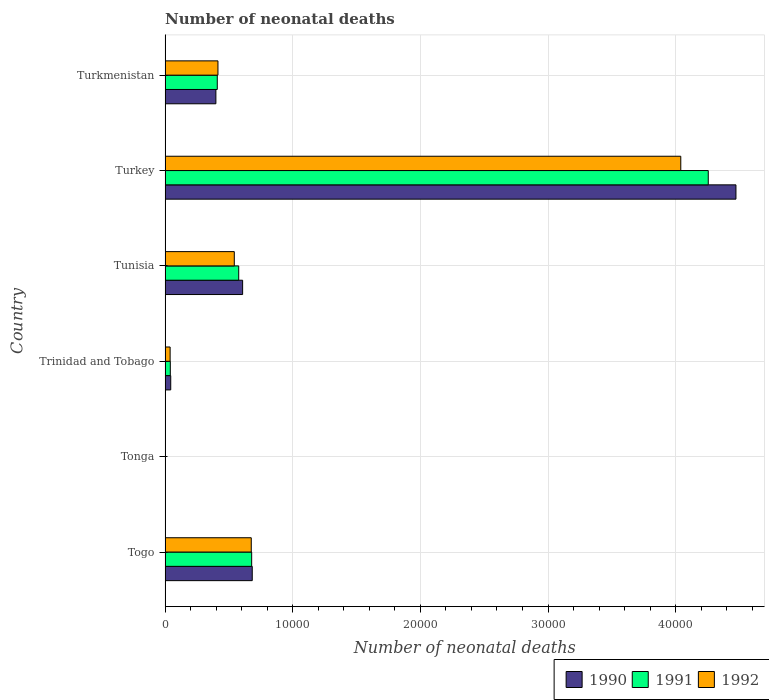How many groups of bars are there?
Provide a succinct answer. 6. Are the number of bars per tick equal to the number of legend labels?
Your answer should be compact. Yes. How many bars are there on the 2nd tick from the top?
Keep it short and to the point. 3. How many bars are there on the 2nd tick from the bottom?
Provide a short and direct response. 3. What is the label of the 3rd group of bars from the top?
Keep it short and to the point. Tunisia. What is the number of neonatal deaths in in 1990 in Tunisia?
Make the answer very short. 6074. Across all countries, what is the maximum number of neonatal deaths in in 1990?
Provide a short and direct response. 4.47e+04. Across all countries, what is the minimum number of neonatal deaths in in 1990?
Ensure brevity in your answer.  26. In which country was the number of neonatal deaths in in 1991 minimum?
Your response must be concise. Tonga. What is the total number of neonatal deaths in in 1992 in the graph?
Keep it short and to the point. 5.71e+04. What is the difference between the number of neonatal deaths in in 1991 in Togo and that in Trinidad and Tobago?
Offer a very short reply. 6374. What is the difference between the number of neonatal deaths in in 1991 in Tonga and the number of neonatal deaths in in 1992 in Turkey?
Ensure brevity in your answer.  -4.04e+04. What is the average number of neonatal deaths in in 1990 per country?
Make the answer very short. 1.03e+04. What is the difference between the number of neonatal deaths in in 1991 and number of neonatal deaths in in 1990 in Trinidad and Tobago?
Provide a succinct answer. -33. What is the ratio of the number of neonatal deaths in in 1991 in Togo to that in Turkmenistan?
Your answer should be compact. 1.66. Is the number of neonatal deaths in in 1992 in Togo less than that in Turkey?
Your response must be concise. Yes. Is the difference between the number of neonatal deaths in in 1991 in Tonga and Tunisia greater than the difference between the number of neonatal deaths in in 1990 in Tonga and Tunisia?
Ensure brevity in your answer.  Yes. What is the difference between the highest and the second highest number of neonatal deaths in in 1991?
Provide a succinct answer. 3.58e+04. What is the difference between the highest and the lowest number of neonatal deaths in in 1990?
Your answer should be very brief. 4.47e+04. Is the sum of the number of neonatal deaths in in 1992 in Togo and Tunisia greater than the maximum number of neonatal deaths in in 1990 across all countries?
Your answer should be compact. No. Is it the case that in every country, the sum of the number of neonatal deaths in in 1991 and number of neonatal deaths in in 1990 is greater than the number of neonatal deaths in in 1992?
Offer a terse response. Yes. How many countries are there in the graph?
Provide a short and direct response. 6. What is the difference between two consecutive major ticks on the X-axis?
Give a very brief answer. 10000. How many legend labels are there?
Offer a terse response. 3. How are the legend labels stacked?
Offer a terse response. Horizontal. What is the title of the graph?
Your answer should be compact. Number of neonatal deaths. What is the label or title of the X-axis?
Your response must be concise. Number of neonatal deaths. What is the Number of neonatal deaths in 1990 in Togo?
Keep it short and to the point. 6828. What is the Number of neonatal deaths in 1991 in Togo?
Provide a short and direct response. 6783. What is the Number of neonatal deaths of 1992 in Togo?
Your answer should be very brief. 6751. What is the Number of neonatal deaths in 1990 in Tonga?
Make the answer very short. 26. What is the Number of neonatal deaths of 1990 in Trinidad and Tobago?
Provide a succinct answer. 442. What is the Number of neonatal deaths in 1991 in Trinidad and Tobago?
Provide a succinct answer. 409. What is the Number of neonatal deaths in 1992 in Trinidad and Tobago?
Make the answer very short. 394. What is the Number of neonatal deaths of 1990 in Tunisia?
Provide a short and direct response. 6074. What is the Number of neonatal deaths in 1991 in Tunisia?
Your answer should be compact. 5768. What is the Number of neonatal deaths in 1992 in Tunisia?
Make the answer very short. 5421. What is the Number of neonatal deaths in 1990 in Turkey?
Give a very brief answer. 4.47e+04. What is the Number of neonatal deaths of 1991 in Turkey?
Give a very brief answer. 4.26e+04. What is the Number of neonatal deaths of 1992 in Turkey?
Offer a very short reply. 4.04e+04. What is the Number of neonatal deaths in 1990 in Turkmenistan?
Offer a terse response. 3979. What is the Number of neonatal deaths in 1991 in Turkmenistan?
Make the answer very short. 4088. What is the Number of neonatal deaths in 1992 in Turkmenistan?
Make the answer very short. 4141. Across all countries, what is the maximum Number of neonatal deaths in 1990?
Your answer should be very brief. 4.47e+04. Across all countries, what is the maximum Number of neonatal deaths in 1991?
Your response must be concise. 4.26e+04. Across all countries, what is the maximum Number of neonatal deaths in 1992?
Give a very brief answer. 4.04e+04. Across all countries, what is the minimum Number of neonatal deaths of 1990?
Make the answer very short. 26. Across all countries, what is the minimum Number of neonatal deaths of 1992?
Offer a very short reply. 25. What is the total Number of neonatal deaths in 1990 in the graph?
Provide a short and direct response. 6.21e+04. What is the total Number of neonatal deaths of 1991 in the graph?
Make the answer very short. 5.96e+04. What is the total Number of neonatal deaths in 1992 in the graph?
Provide a short and direct response. 5.71e+04. What is the difference between the Number of neonatal deaths of 1990 in Togo and that in Tonga?
Your answer should be very brief. 6802. What is the difference between the Number of neonatal deaths in 1991 in Togo and that in Tonga?
Provide a succinct answer. 6758. What is the difference between the Number of neonatal deaths of 1992 in Togo and that in Tonga?
Offer a terse response. 6726. What is the difference between the Number of neonatal deaths of 1990 in Togo and that in Trinidad and Tobago?
Your answer should be compact. 6386. What is the difference between the Number of neonatal deaths of 1991 in Togo and that in Trinidad and Tobago?
Provide a short and direct response. 6374. What is the difference between the Number of neonatal deaths of 1992 in Togo and that in Trinidad and Tobago?
Give a very brief answer. 6357. What is the difference between the Number of neonatal deaths of 1990 in Togo and that in Tunisia?
Your answer should be very brief. 754. What is the difference between the Number of neonatal deaths of 1991 in Togo and that in Tunisia?
Provide a succinct answer. 1015. What is the difference between the Number of neonatal deaths in 1992 in Togo and that in Tunisia?
Ensure brevity in your answer.  1330. What is the difference between the Number of neonatal deaths of 1990 in Togo and that in Turkey?
Offer a terse response. -3.79e+04. What is the difference between the Number of neonatal deaths in 1991 in Togo and that in Turkey?
Offer a terse response. -3.58e+04. What is the difference between the Number of neonatal deaths of 1992 in Togo and that in Turkey?
Offer a terse response. -3.36e+04. What is the difference between the Number of neonatal deaths in 1990 in Togo and that in Turkmenistan?
Provide a succinct answer. 2849. What is the difference between the Number of neonatal deaths in 1991 in Togo and that in Turkmenistan?
Your answer should be very brief. 2695. What is the difference between the Number of neonatal deaths of 1992 in Togo and that in Turkmenistan?
Make the answer very short. 2610. What is the difference between the Number of neonatal deaths of 1990 in Tonga and that in Trinidad and Tobago?
Your answer should be very brief. -416. What is the difference between the Number of neonatal deaths of 1991 in Tonga and that in Trinidad and Tobago?
Provide a succinct answer. -384. What is the difference between the Number of neonatal deaths in 1992 in Tonga and that in Trinidad and Tobago?
Provide a short and direct response. -369. What is the difference between the Number of neonatal deaths in 1990 in Tonga and that in Tunisia?
Keep it short and to the point. -6048. What is the difference between the Number of neonatal deaths in 1991 in Tonga and that in Tunisia?
Your response must be concise. -5743. What is the difference between the Number of neonatal deaths of 1992 in Tonga and that in Tunisia?
Your response must be concise. -5396. What is the difference between the Number of neonatal deaths of 1990 in Tonga and that in Turkey?
Your response must be concise. -4.47e+04. What is the difference between the Number of neonatal deaths in 1991 in Tonga and that in Turkey?
Your response must be concise. -4.25e+04. What is the difference between the Number of neonatal deaths in 1992 in Tonga and that in Turkey?
Offer a very short reply. -4.04e+04. What is the difference between the Number of neonatal deaths of 1990 in Tonga and that in Turkmenistan?
Give a very brief answer. -3953. What is the difference between the Number of neonatal deaths of 1991 in Tonga and that in Turkmenistan?
Keep it short and to the point. -4063. What is the difference between the Number of neonatal deaths of 1992 in Tonga and that in Turkmenistan?
Provide a short and direct response. -4116. What is the difference between the Number of neonatal deaths of 1990 in Trinidad and Tobago and that in Tunisia?
Offer a very short reply. -5632. What is the difference between the Number of neonatal deaths in 1991 in Trinidad and Tobago and that in Tunisia?
Give a very brief answer. -5359. What is the difference between the Number of neonatal deaths of 1992 in Trinidad and Tobago and that in Tunisia?
Offer a very short reply. -5027. What is the difference between the Number of neonatal deaths of 1990 in Trinidad and Tobago and that in Turkey?
Your answer should be compact. -4.43e+04. What is the difference between the Number of neonatal deaths of 1991 in Trinidad and Tobago and that in Turkey?
Make the answer very short. -4.21e+04. What is the difference between the Number of neonatal deaths of 1992 in Trinidad and Tobago and that in Turkey?
Make the answer very short. -4.00e+04. What is the difference between the Number of neonatal deaths in 1990 in Trinidad and Tobago and that in Turkmenistan?
Offer a terse response. -3537. What is the difference between the Number of neonatal deaths in 1991 in Trinidad and Tobago and that in Turkmenistan?
Give a very brief answer. -3679. What is the difference between the Number of neonatal deaths in 1992 in Trinidad and Tobago and that in Turkmenistan?
Provide a succinct answer. -3747. What is the difference between the Number of neonatal deaths of 1990 in Tunisia and that in Turkey?
Offer a very short reply. -3.86e+04. What is the difference between the Number of neonatal deaths of 1991 in Tunisia and that in Turkey?
Your response must be concise. -3.68e+04. What is the difference between the Number of neonatal deaths in 1992 in Tunisia and that in Turkey?
Your answer should be very brief. -3.50e+04. What is the difference between the Number of neonatal deaths of 1990 in Tunisia and that in Turkmenistan?
Your answer should be compact. 2095. What is the difference between the Number of neonatal deaths of 1991 in Tunisia and that in Turkmenistan?
Your answer should be compact. 1680. What is the difference between the Number of neonatal deaths in 1992 in Tunisia and that in Turkmenistan?
Offer a terse response. 1280. What is the difference between the Number of neonatal deaths of 1990 in Turkey and that in Turkmenistan?
Your response must be concise. 4.07e+04. What is the difference between the Number of neonatal deaths in 1991 in Turkey and that in Turkmenistan?
Provide a succinct answer. 3.85e+04. What is the difference between the Number of neonatal deaths in 1992 in Turkey and that in Turkmenistan?
Give a very brief answer. 3.63e+04. What is the difference between the Number of neonatal deaths in 1990 in Togo and the Number of neonatal deaths in 1991 in Tonga?
Ensure brevity in your answer.  6803. What is the difference between the Number of neonatal deaths of 1990 in Togo and the Number of neonatal deaths of 1992 in Tonga?
Your answer should be compact. 6803. What is the difference between the Number of neonatal deaths in 1991 in Togo and the Number of neonatal deaths in 1992 in Tonga?
Provide a short and direct response. 6758. What is the difference between the Number of neonatal deaths in 1990 in Togo and the Number of neonatal deaths in 1991 in Trinidad and Tobago?
Offer a terse response. 6419. What is the difference between the Number of neonatal deaths of 1990 in Togo and the Number of neonatal deaths of 1992 in Trinidad and Tobago?
Provide a short and direct response. 6434. What is the difference between the Number of neonatal deaths of 1991 in Togo and the Number of neonatal deaths of 1992 in Trinidad and Tobago?
Make the answer very short. 6389. What is the difference between the Number of neonatal deaths in 1990 in Togo and the Number of neonatal deaths in 1991 in Tunisia?
Provide a succinct answer. 1060. What is the difference between the Number of neonatal deaths in 1990 in Togo and the Number of neonatal deaths in 1992 in Tunisia?
Ensure brevity in your answer.  1407. What is the difference between the Number of neonatal deaths of 1991 in Togo and the Number of neonatal deaths of 1992 in Tunisia?
Your answer should be compact. 1362. What is the difference between the Number of neonatal deaths in 1990 in Togo and the Number of neonatal deaths in 1991 in Turkey?
Your answer should be very brief. -3.57e+04. What is the difference between the Number of neonatal deaths in 1990 in Togo and the Number of neonatal deaths in 1992 in Turkey?
Provide a short and direct response. -3.36e+04. What is the difference between the Number of neonatal deaths of 1991 in Togo and the Number of neonatal deaths of 1992 in Turkey?
Keep it short and to the point. -3.36e+04. What is the difference between the Number of neonatal deaths in 1990 in Togo and the Number of neonatal deaths in 1991 in Turkmenistan?
Provide a short and direct response. 2740. What is the difference between the Number of neonatal deaths in 1990 in Togo and the Number of neonatal deaths in 1992 in Turkmenistan?
Your answer should be very brief. 2687. What is the difference between the Number of neonatal deaths of 1991 in Togo and the Number of neonatal deaths of 1992 in Turkmenistan?
Provide a succinct answer. 2642. What is the difference between the Number of neonatal deaths of 1990 in Tonga and the Number of neonatal deaths of 1991 in Trinidad and Tobago?
Keep it short and to the point. -383. What is the difference between the Number of neonatal deaths of 1990 in Tonga and the Number of neonatal deaths of 1992 in Trinidad and Tobago?
Offer a terse response. -368. What is the difference between the Number of neonatal deaths in 1991 in Tonga and the Number of neonatal deaths in 1992 in Trinidad and Tobago?
Keep it short and to the point. -369. What is the difference between the Number of neonatal deaths of 1990 in Tonga and the Number of neonatal deaths of 1991 in Tunisia?
Your response must be concise. -5742. What is the difference between the Number of neonatal deaths of 1990 in Tonga and the Number of neonatal deaths of 1992 in Tunisia?
Give a very brief answer. -5395. What is the difference between the Number of neonatal deaths of 1991 in Tonga and the Number of neonatal deaths of 1992 in Tunisia?
Provide a short and direct response. -5396. What is the difference between the Number of neonatal deaths in 1990 in Tonga and the Number of neonatal deaths in 1991 in Turkey?
Give a very brief answer. -4.25e+04. What is the difference between the Number of neonatal deaths of 1990 in Tonga and the Number of neonatal deaths of 1992 in Turkey?
Keep it short and to the point. -4.04e+04. What is the difference between the Number of neonatal deaths in 1991 in Tonga and the Number of neonatal deaths in 1992 in Turkey?
Provide a succinct answer. -4.04e+04. What is the difference between the Number of neonatal deaths in 1990 in Tonga and the Number of neonatal deaths in 1991 in Turkmenistan?
Offer a very short reply. -4062. What is the difference between the Number of neonatal deaths of 1990 in Tonga and the Number of neonatal deaths of 1992 in Turkmenistan?
Ensure brevity in your answer.  -4115. What is the difference between the Number of neonatal deaths of 1991 in Tonga and the Number of neonatal deaths of 1992 in Turkmenistan?
Give a very brief answer. -4116. What is the difference between the Number of neonatal deaths in 1990 in Trinidad and Tobago and the Number of neonatal deaths in 1991 in Tunisia?
Offer a terse response. -5326. What is the difference between the Number of neonatal deaths of 1990 in Trinidad and Tobago and the Number of neonatal deaths of 1992 in Tunisia?
Provide a short and direct response. -4979. What is the difference between the Number of neonatal deaths of 1991 in Trinidad and Tobago and the Number of neonatal deaths of 1992 in Tunisia?
Keep it short and to the point. -5012. What is the difference between the Number of neonatal deaths of 1990 in Trinidad and Tobago and the Number of neonatal deaths of 1991 in Turkey?
Offer a terse response. -4.21e+04. What is the difference between the Number of neonatal deaths in 1990 in Trinidad and Tobago and the Number of neonatal deaths in 1992 in Turkey?
Make the answer very short. -4.00e+04. What is the difference between the Number of neonatal deaths of 1991 in Trinidad and Tobago and the Number of neonatal deaths of 1992 in Turkey?
Provide a short and direct response. -4.00e+04. What is the difference between the Number of neonatal deaths of 1990 in Trinidad and Tobago and the Number of neonatal deaths of 1991 in Turkmenistan?
Your response must be concise. -3646. What is the difference between the Number of neonatal deaths in 1990 in Trinidad and Tobago and the Number of neonatal deaths in 1992 in Turkmenistan?
Ensure brevity in your answer.  -3699. What is the difference between the Number of neonatal deaths in 1991 in Trinidad and Tobago and the Number of neonatal deaths in 1992 in Turkmenistan?
Provide a short and direct response. -3732. What is the difference between the Number of neonatal deaths of 1990 in Tunisia and the Number of neonatal deaths of 1991 in Turkey?
Your response must be concise. -3.65e+04. What is the difference between the Number of neonatal deaths in 1990 in Tunisia and the Number of neonatal deaths in 1992 in Turkey?
Ensure brevity in your answer.  -3.43e+04. What is the difference between the Number of neonatal deaths in 1991 in Tunisia and the Number of neonatal deaths in 1992 in Turkey?
Keep it short and to the point. -3.46e+04. What is the difference between the Number of neonatal deaths in 1990 in Tunisia and the Number of neonatal deaths in 1991 in Turkmenistan?
Offer a terse response. 1986. What is the difference between the Number of neonatal deaths of 1990 in Tunisia and the Number of neonatal deaths of 1992 in Turkmenistan?
Give a very brief answer. 1933. What is the difference between the Number of neonatal deaths of 1991 in Tunisia and the Number of neonatal deaths of 1992 in Turkmenistan?
Provide a succinct answer. 1627. What is the difference between the Number of neonatal deaths in 1990 in Turkey and the Number of neonatal deaths in 1991 in Turkmenistan?
Give a very brief answer. 4.06e+04. What is the difference between the Number of neonatal deaths of 1990 in Turkey and the Number of neonatal deaths of 1992 in Turkmenistan?
Your answer should be very brief. 4.06e+04. What is the difference between the Number of neonatal deaths of 1991 in Turkey and the Number of neonatal deaths of 1992 in Turkmenistan?
Your answer should be very brief. 3.84e+04. What is the average Number of neonatal deaths in 1990 per country?
Keep it short and to the point. 1.03e+04. What is the average Number of neonatal deaths of 1991 per country?
Your response must be concise. 9937.67. What is the average Number of neonatal deaths in 1992 per country?
Make the answer very short. 9522. What is the difference between the Number of neonatal deaths in 1990 and Number of neonatal deaths in 1992 in Togo?
Keep it short and to the point. 77. What is the difference between the Number of neonatal deaths of 1990 and Number of neonatal deaths of 1991 in Tonga?
Offer a very short reply. 1. What is the difference between the Number of neonatal deaths of 1990 and Number of neonatal deaths of 1992 in Tonga?
Offer a terse response. 1. What is the difference between the Number of neonatal deaths in 1991 and Number of neonatal deaths in 1992 in Tonga?
Provide a succinct answer. 0. What is the difference between the Number of neonatal deaths in 1990 and Number of neonatal deaths in 1992 in Trinidad and Tobago?
Provide a succinct answer. 48. What is the difference between the Number of neonatal deaths of 1991 and Number of neonatal deaths of 1992 in Trinidad and Tobago?
Ensure brevity in your answer.  15. What is the difference between the Number of neonatal deaths in 1990 and Number of neonatal deaths in 1991 in Tunisia?
Make the answer very short. 306. What is the difference between the Number of neonatal deaths of 1990 and Number of neonatal deaths of 1992 in Tunisia?
Offer a terse response. 653. What is the difference between the Number of neonatal deaths in 1991 and Number of neonatal deaths in 1992 in Tunisia?
Offer a terse response. 347. What is the difference between the Number of neonatal deaths of 1990 and Number of neonatal deaths of 1991 in Turkey?
Your answer should be compact. 2169. What is the difference between the Number of neonatal deaths of 1990 and Number of neonatal deaths of 1992 in Turkey?
Your answer should be very brief. 4322. What is the difference between the Number of neonatal deaths in 1991 and Number of neonatal deaths in 1992 in Turkey?
Give a very brief answer. 2153. What is the difference between the Number of neonatal deaths of 1990 and Number of neonatal deaths of 1991 in Turkmenistan?
Provide a short and direct response. -109. What is the difference between the Number of neonatal deaths in 1990 and Number of neonatal deaths in 1992 in Turkmenistan?
Provide a short and direct response. -162. What is the difference between the Number of neonatal deaths of 1991 and Number of neonatal deaths of 1992 in Turkmenistan?
Your answer should be very brief. -53. What is the ratio of the Number of neonatal deaths in 1990 in Togo to that in Tonga?
Ensure brevity in your answer.  262.62. What is the ratio of the Number of neonatal deaths of 1991 in Togo to that in Tonga?
Offer a very short reply. 271.32. What is the ratio of the Number of neonatal deaths of 1992 in Togo to that in Tonga?
Your answer should be compact. 270.04. What is the ratio of the Number of neonatal deaths in 1990 in Togo to that in Trinidad and Tobago?
Provide a succinct answer. 15.45. What is the ratio of the Number of neonatal deaths of 1991 in Togo to that in Trinidad and Tobago?
Your answer should be compact. 16.58. What is the ratio of the Number of neonatal deaths of 1992 in Togo to that in Trinidad and Tobago?
Offer a terse response. 17.13. What is the ratio of the Number of neonatal deaths of 1990 in Togo to that in Tunisia?
Give a very brief answer. 1.12. What is the ratio of the Number of neonatal deaths in 1991 in Togo to that in Tunisia?
Your response must be concise. 1.18. What is the ratio of the Number of neonatal deaths of 1992 in Togo to that in Tunisia?
Your response must be concise. 1.25. What is the ratio of the Number of neonatal deaths in 1990 in Togo to that in Turkey?
Your response must be concise. 0.15. What is the ratio of the Number of neonatal deaths in 1991 in Togo to that in Turkey?
Give a very brief answer. 0.16. What is the ratio of the Number of neonatal deaths of 1992 in Togo to that in Turkey?
Keep it short and to the point. 0.17. What is the ratio of the Number of neonatal deaths in 1990 in Togo to that in Turkmenistan?
Your answer should be very brief. 1.72. What is the ratio of the Number of neonatal deaths of 1991 in Togo to that in Turkmenistan?
Offer a very short reply. 1.66. What is the ratio of the Number of neonatal deaths in 1992 in Togo to that in Turkmenistan?
Give a very brief answer. 1.63. What is the ratio of the Number of neonatal deaths of 1990 in Tonga to that in Trinidad and Tobago?
Ensure brevity in your answer.  0.06. What is the ratio of the Number of neonatal deaths of 1991 in Tonga to that in Trinidad and Tobago?
Ensure brevity in your answer.  0.06. What is the ratio of the Number of neonatal deaths of 1992 in Tonga to that in Trinidad and Tobago?
Offer a terse response. 0.06. What is the ratio of the Number of neonatal deaths of 1990 in Tonga to that in Tunisia?
Give a very brief answer. 0. What is the ratio of the Number of neonatal deaths of 1991 in Tonga to that in Tunisia?
Your response must be concise. 0. What is the ratio of the Number of neonatal deaths in 1992 in Tonga to that in Tunisia?
Your response must be concise. 0. What is the ratio of the Number of neonatal deaths in 1990 in Tonga to that in Turkey?
Provide a succinct answer. 0. What is the ratio of the Number of neonatal deaths of 1991 in Tonga to that in Turkey?
Ensure brevity in your answer.  0. What is the ratio of the Number of neonatal deaths in 1992 in Tonga to that in Turkey?
Your answer should be very brief. 0. What is the ratio of the Number of neonatal deaths in 1990 in Tonga to that in Turkmenistan?
Offer a terse response. 0.01. What is the ratio of the Number of neonatal deaths of 1991 in Tonga to that in Turkmenistan?
Offer a terse response. 0.01. What is the ratio of the Number of neonatal deaths of 1992 in Tonga to that in Turkmenistan?
Provide a short and direct response. 0.01. What is the ratio of the Number of neonatal deaths in 1990 in Trinidad and Tobago to that in Tunisia?
Your response must be concise. 0.07. What is the ratio of the Number of neonatal deaths in 1991 in Trinidad and Tobago to that in Tunisia?
Your answer should be compact. 0.07. What is the ratio of the Number of neonatal deaths in 1992 in Trinidad and Tobago to that in Tunisia?
Offer a terse response. 0.07. What is the ratio of the Number of neonatal deaths of 1990 in Trinidad and Tobago to that in Turkey?
Offer a terse response. 0.01. What is the ratio of the Number of neonatal deaths of 1991 in Trinidad and Tobago to that in Turkey?
Your answer should be compact. 0.01. What is the ratio of the Number of neonatal deaths in 1992 in Trinidad and Tobago to that in Turkey?
Ensure brevity in your answer.  0.01. What is the ratio of the Number of neonatal deaths of 1990 in Trinidad and Tobago to that in Turkmenistan?
Ensure brevity in your answer.  0.11. What is the ratio of the Number of neonatal deaths in 1991 in Trinidad and Tobago to that in Turkmenistan?
Your answer should be very brief. 0.1. What is the ratio of the Number of neonatal deaths in 1992 in Trinidad and Tobago to that in Turkmenistan?
Your response must be concise. 0.1. What is the ratio of the Number of neonatal deaths of 1990 in Tunisia to that in Turkey?
Your response must be concise. 0.14. What is the ratio of the Number of neonatal deaths in 1991 in Tunisia to that in Turkey?
Give a very brief answer. 0.14. What is the ratio of the Number of neonatal deaths of 1992 in Tunisia to that in Turkey?
Provide a short and direct response. 0.13. What is the ratio of the Number of neonatal deaths in 1990 in Tunisia to that in Turkmenistan?
Offer a terse response. 1.53. What is the ratio of the Number of neonatal deaths in 1991 in Tunisia to that in Turkmenistan?
Your answer should be compact. 1.41. What is the ratio of the Number of neonatal deaths of 1992 in Tunisia to that in Turkmenistan?
Make the answer very short. 1.31. What is the ratio of the Number of neonatal deaths in 1990 in Turkey to that in Turkmenistan?
Give a very brief answer. 11.24. What is the ratio of the Number of neonatal deaths of 1991 in Turkey to that in Turkmenistan?
Keep it short and to the point. 10.41. What is the ratio of the Number of neonatal deaths of 1992 in Turkey to that in Turkmenistan?
Keep it short and to the point. 9.76. What is the difference between the highest and the second highest Number of neonatal deaths in 1990?
Make the answer very short. 3.79e+04. What is the difference between the highest and the second highest Number of neonatal deaths in 1991?
Offer a terse response. 3.58e+04. What is the difference between the highest and the second highest Number of neonatal deaths in 1992?
Your answer should be compact. 3.36e+04. What is the difference between the highest and the lowest Number of neonatal deaths in 1990?
Provide a short and direct response. 4.47e+04. What is the difference between the highest and the lowest Number of neonatal deaths of 1991?
Provide a succinct answer. 4.25e+04. What is the difference between the highest and the lowest Number of neonatal deaths of 1992?
Offer a very short reply. 4.04e+04. 